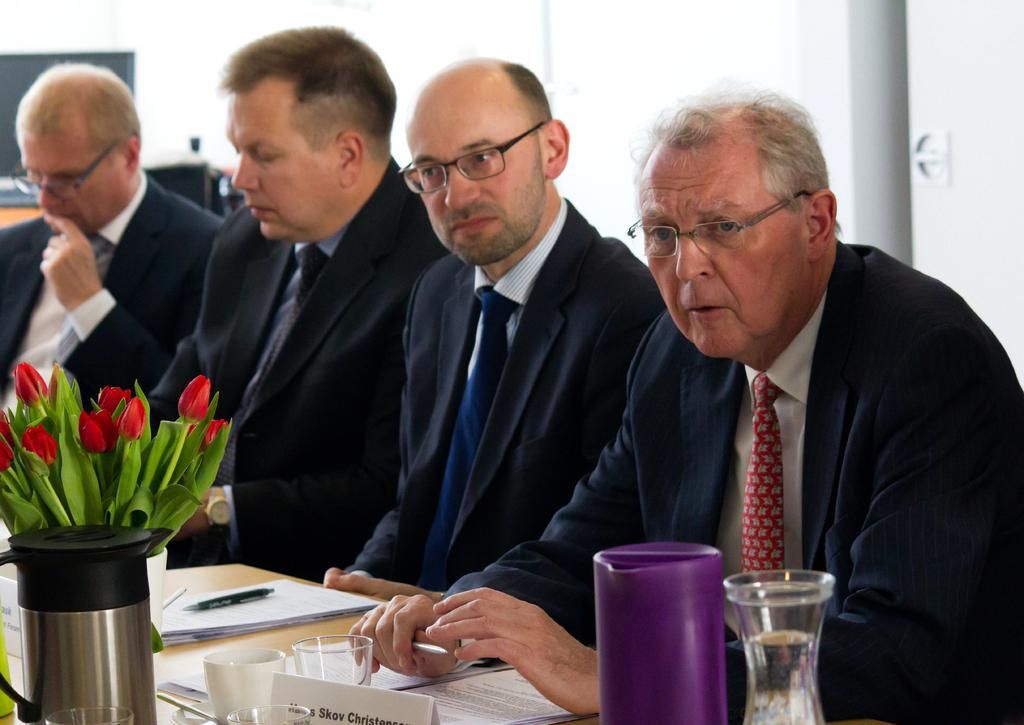What are the people in the image doing? There are persons sitting at the table in the image. What can be seen on the table besides the people? There is a flower vase, papers, a pen, and glasses on the table. What is visible in the background of the image? There is a wall and a monitor in the background of the image. What type of sheet is covering the doll in the image? There is no doll or sheet present in the image. 